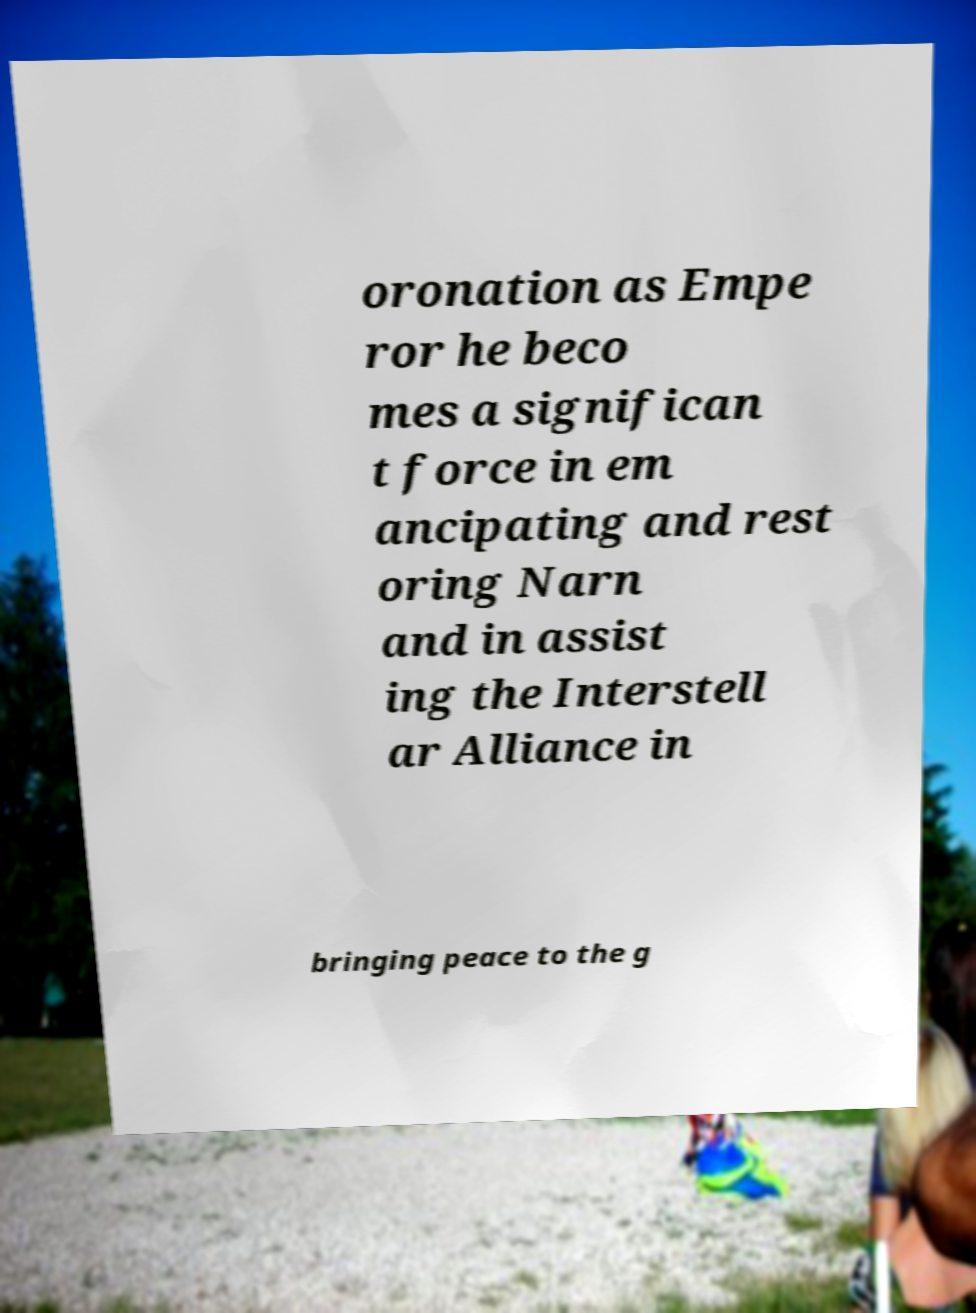Can you read and provide the text displayed in the image?This photo seems to have some interesting text. Can you extract and type it out for me? oronation as Empe ror he beco mes a significan t force in em ancipating and rest oring Narn and in assist ing the Interstell ar Alliance in bringing peace to the g 